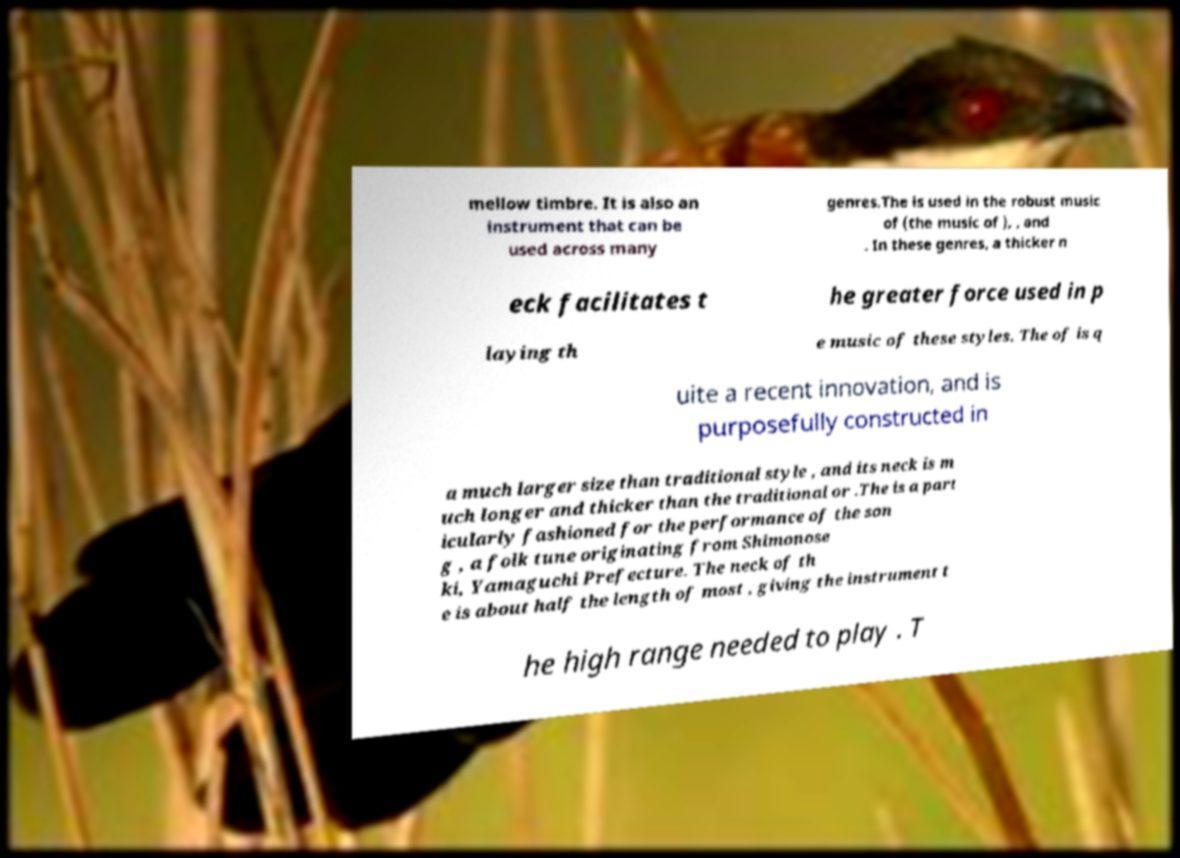Can you read and provide the text displayed in the image?This photo seems to have some interesting text. Can you extract and type it out for me? mellow timbre. It is also an instrument that can be used across many genres.The is used in the robust music of (the music of ), , and . In these genres, a thicker n eck facilitates t he greater force used in p laying th e music of these styles. The of is q uite a recent innovation, and is purposefully constructed in a much larger size than traditional style , and its neck is m uch longer and thicker than the traditional or .The is a part icularly fashioned for the performance of the son g , a folk tune originating from Shimonose ki, Yamaguchi Prefecture. The neck of th e is about half the length of most , giving the instrument t he high range needed to play . T 